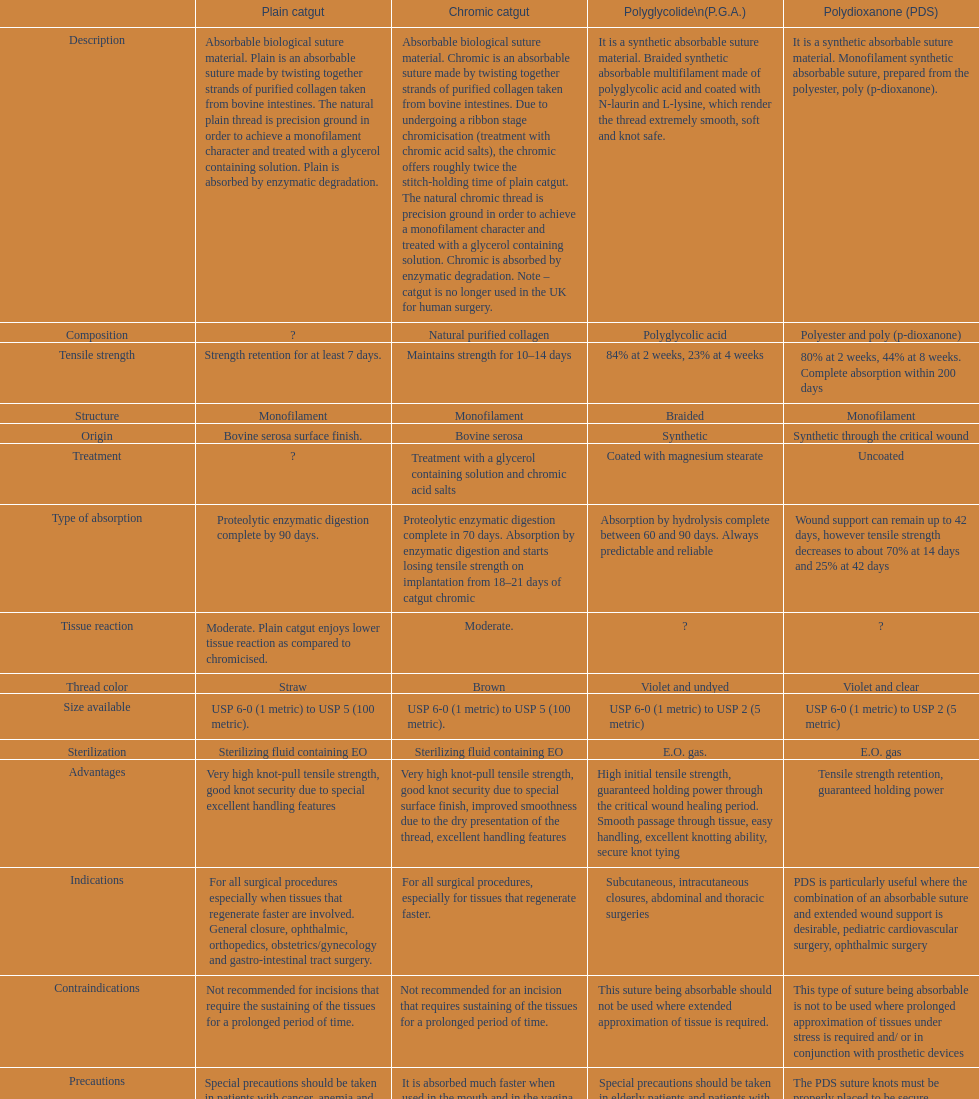The plain catgut maintains its strength for at least how many number of days? Strength retention for at least 7 days. 